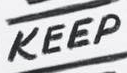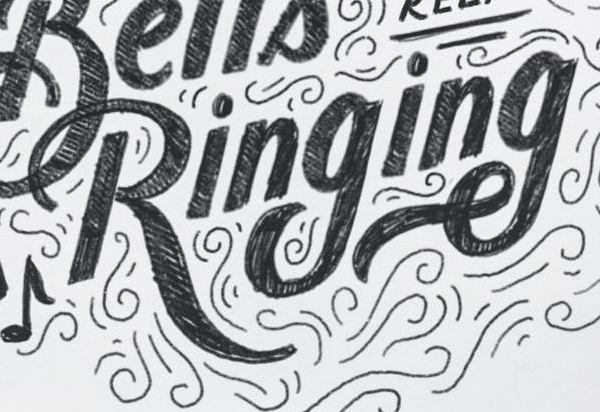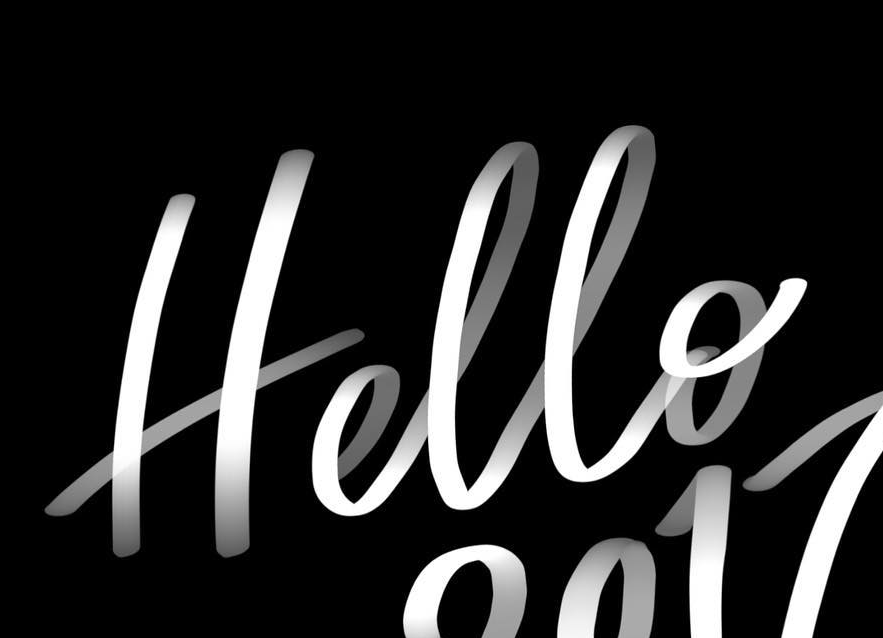Read the text content from these images in order, separated by a semicolon. KEEP; Ringing; Hello 